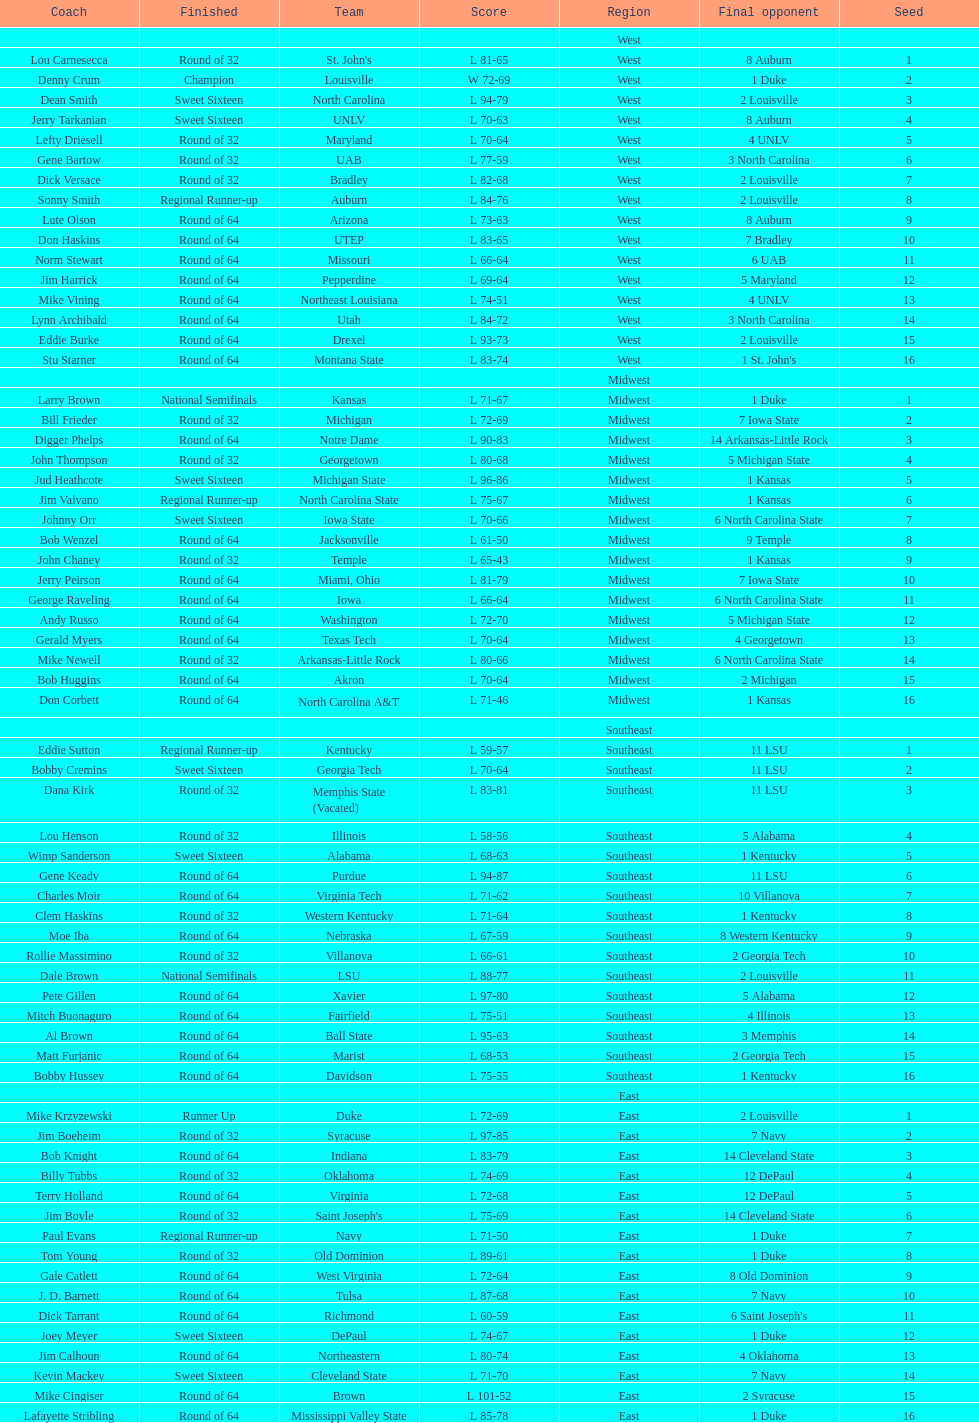How many 1 seeds are there? 4. 